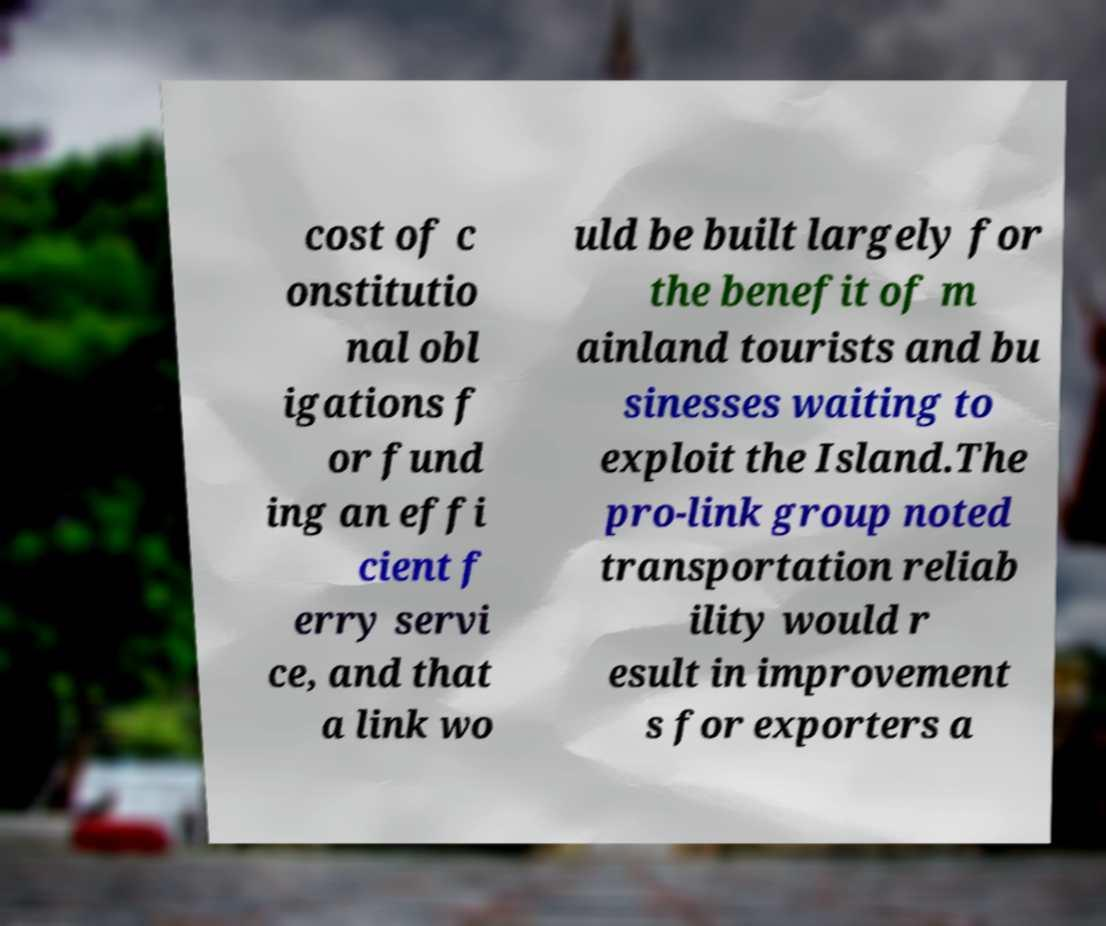Could you assist in decoding the text presented in this image and type it out clearly? cost of c onstitutio nal obl igations f or fund ing an effi cient f erry servi ce, and that a link wo uld be built largely for the benefit of m ainland tourists and bu sinesses waiting to exploit the Island.The pro-link group noted transportation reliab ility would r esult in improvement s for exporters a 